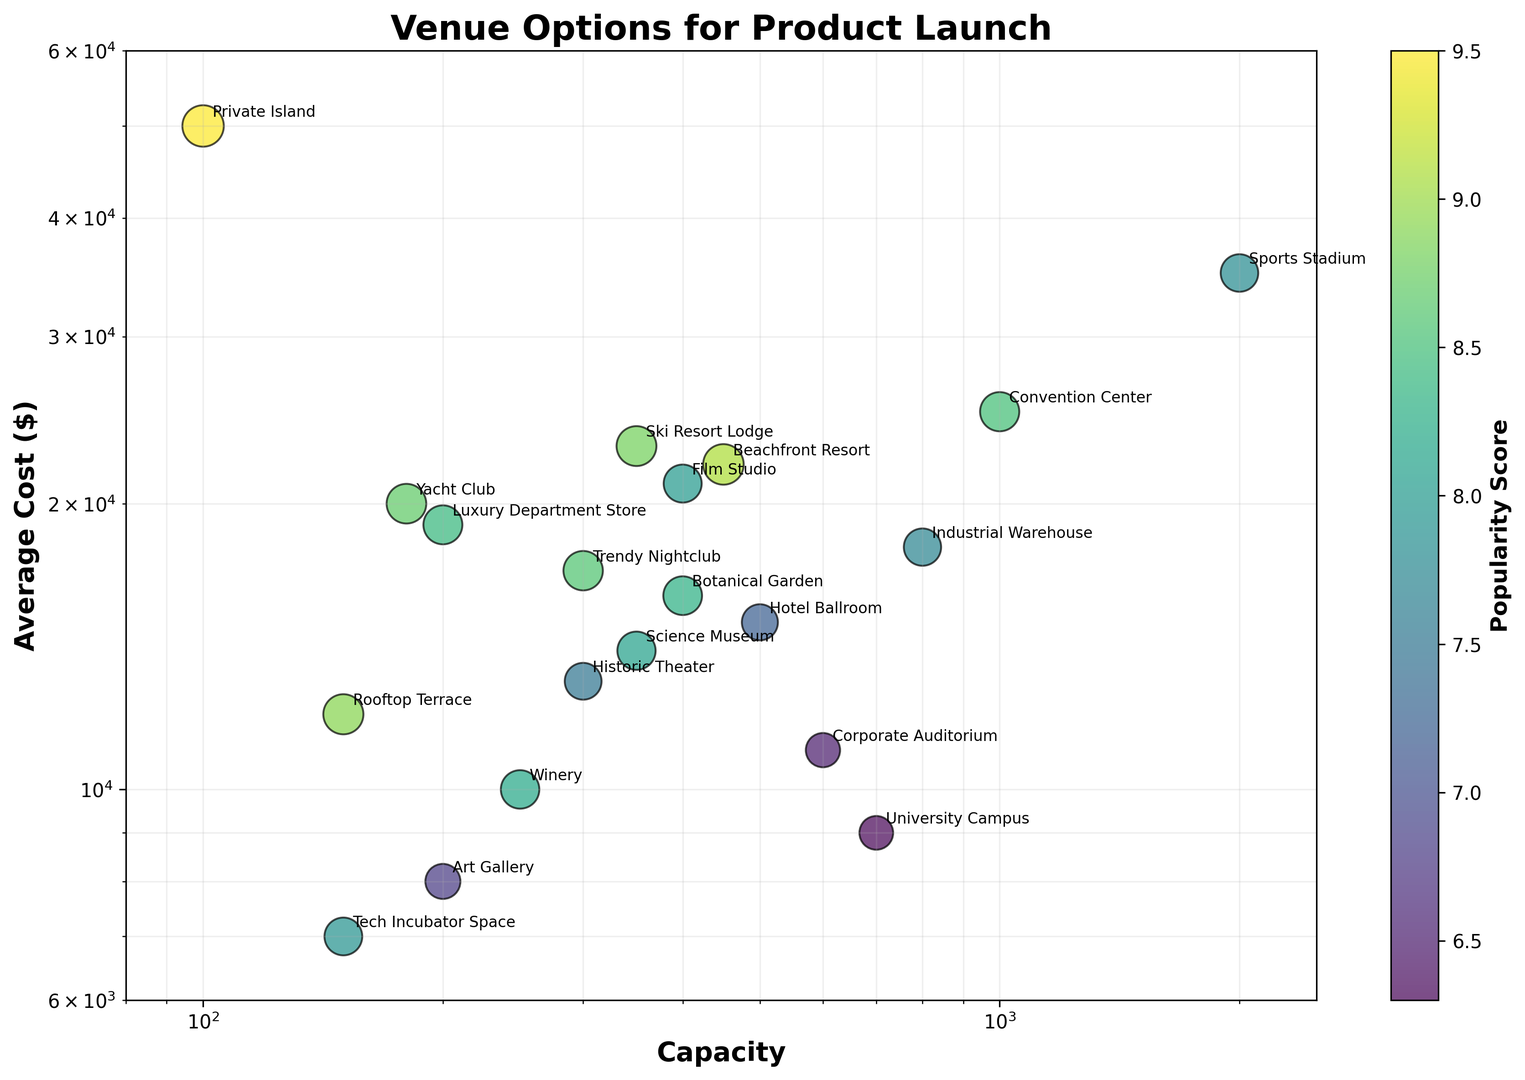Which venue has the highest average cost? Look at the y-axis to identify the highest point on the plot and then find its corresponding label. The highest average cost is represented by "Private Island".
Answer: Private Island Which venue has the lowest capacity? Look at the x-axis to identify the lowest point on the plot and then find its corresponding label. The lowest capacity is "Private Island".
Answer: Private Island What is the combined capacity of the Convention Center and the Sports Stadium? Locate both venues on the x-axis. Convention Center has a capacity of 1000, and Sports Stadium has a capacity of 2000. Add these two values together: 1000 + 2000 = 3000.
Answer: 3000 Which venue has a larger popularity score: the Art Gallery or the Tech Incubator Space? Locate both venues and compare their bubble sizes. The Art Gallery has a popularity score of 6.8, while the Tech Incubator Space has a score of 7.9. The Tech Incubator Space has a larger popularity score.
Answer: Tech Incubator Space Which venue provides the highest popularity score for a capacity below 500? Identify all venues with capacity below 500 by looking at the left part of the x-axis. Compare their popularity scores. Rooftop Terrace and Yacht Club are below 500, with popularity scores of 8.9 and 8.7 respectively. Rooftop Terrace has the highest score.
Answer: Rooftop Terrace How many venues have an average cost greater than $20,000? Identify all points on the y-axis above $20,000 and count them. Points corresponding to "Private Island", "Beachfront Resort", "Film Studio", and "Ski Resort Lodge" have costs above $20,000. The count is 4.
Answer: 4 Which venue has the most balanced combination of capacity and cost (neither too high nor too low)? Identify a point that is roughly in the middle of the x and y axes. The Botanical Garden appears to have a balanced capacity and cost.
Answer: Botanical Garden Which venue among those with a capacity of over 1000 has the lowest popularity score? Identify venues with capacity over 1000 by looking at the far right of the x-axis. Convention Center and Sports Stadium fit this criterion. Compare their popularity scores: Convention Center has 8.5, and Sports Stadium has 7.8. Sports Stadium has the lowest score.
Answer: Sports Stadium What is the difference in average cost between the Yacht Club and the Winery? Identify both venues on the y-axis and note their average costs. Yacht Club has a cost of $20,000, and the Winery has a cost of $10,000. Subtract the two: $20,000 - $10,000 = $10,000.
Answer: $10,000 Which venue with a capacity under 200 has the highest average cost? Identify venues with capacity under 200 by looking at the leftmost part of the x-axis. Compare costs: "Private Island" has the highest cost at $50,000.
Answer: Private Island 